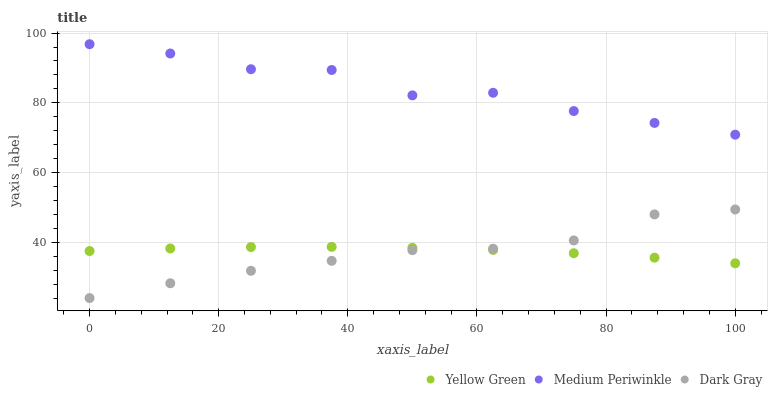Does Dark Gray have the minimum area under the curve?
Answer yes or no. Yes. Does Medium Periwinkle have the maximum area under the curve?
Answer yes or no. Yes. Does Yellow Green have the minimum area under the curve?
Answer yes or no. No. Does Yellow Green have the maximum area under the curve?
Answer yes or no. No. Is Yellow Green the smoothest?
Answer yes or no. Yes. Is Medium Periwinkle the roughest?
Answer yes or no. Yes. Is Medium Periwinkle the smoothest?
Answer yes or no. No. Is Yellow Green the roughest?
Answer yes or no. No. Does Dark Gray have the lowest value?
Answer yes or no. Yes. Does Yellow Green have the lowest value?
Answer yes or no. No. Does Medium Periwinkle have the highest value?
Answer yes or no. Yes. Does Yellow Green have the highest value?
Answer yes or no. No. Is Dark Gray less than Medium Periwinkle?
Answer yes or no. Yes. Is Medium Periwinkle greater than Yellow Green?
Answer yes or no. Yes. Does Yellow Green intersect Dark Gray?
Answer yes or no. Yes. Is Yellow Green less than Dark Gray?
Answer yes or no. No. Is Yellow Green greater than Dark Gray?
Answer yes or no. No. Does Dark Gray intersect Medium Periwinkle?
Answer yes or no. No. 